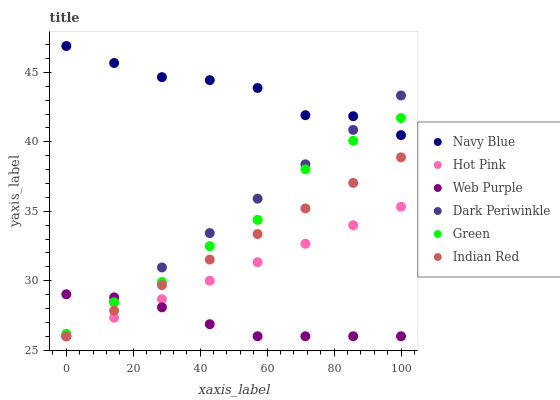Does Web Purple have the minimum area under the curve?
Answer yes or no. Yes. Does Navy Blue have the maximum area under the curve?
Answer yes or no. Yes. Does Hot Pink have the minimum area under the curve?
Answer yes or no. No. Does Hot Pink have the maximum area under the curve?
Answer yes or no. No. Is Indian Red the smoothest?
Answer yes or no. Yes. Is Green the roughest?
Answer yes or no. Yes. Is Hot Pink the smoothest?
Answer yes or no. No. Is Hot Pink the roughest?
Answer yes or no. No. Does Hot Pink have the lowest value?
Answer yes or no. Yes. Does Green have the lowest value?
Answer yes or no. No. Does Navy Blue have the highest value?
Answer yes or no. Yes. Does Hot Pink have the highest value?
Answer yes or no. No. Is Web Purple less than Navy Blue?
Answer yes or no. Yes. Is Green greater than Indian Red?
Answer yes or no. Yes. Does Dark Periwinkle intersect Indian Red?
Answer yes or no. Yes. Is Dark Periwinkle less than Indian Red?
Answer yes or no. No. Is Dark Periwinkle greater than Indian Red?
Answer yes or no. No. Does Web Purple intersect Navy Blue?
Answer yes or no. No. 